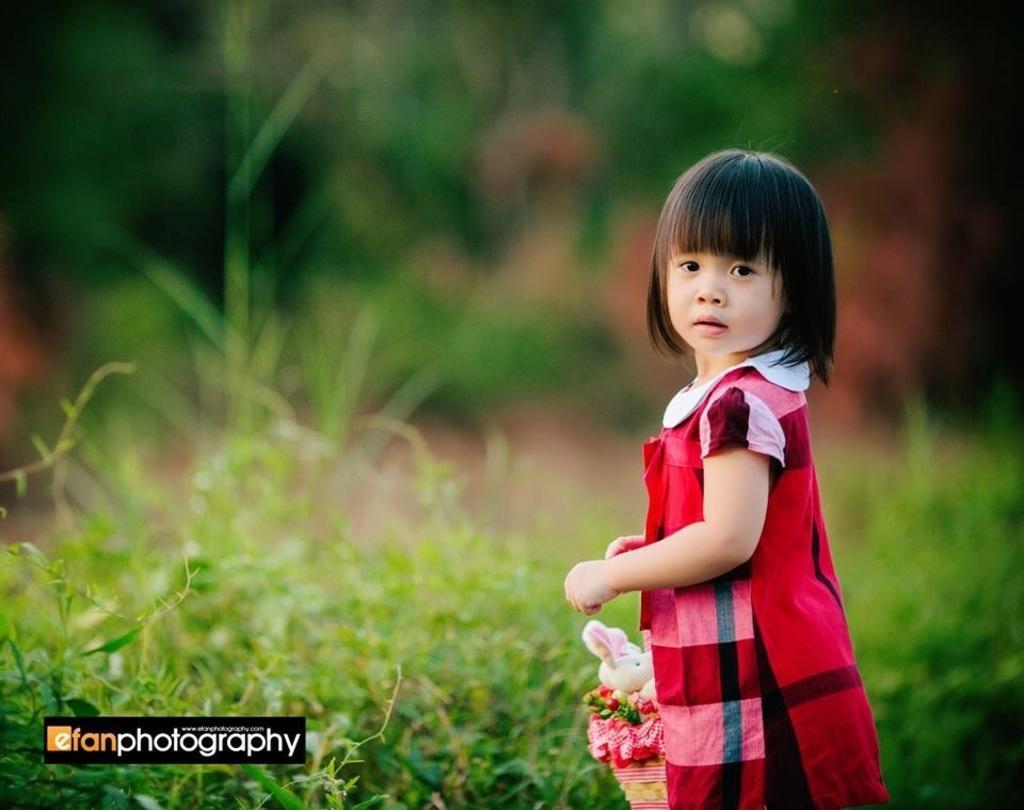Describe this image in one or two sentences. In this image we can see a girl holding a basket with some things like toys and there are some plants and in the background, we can see the image is blurred. 